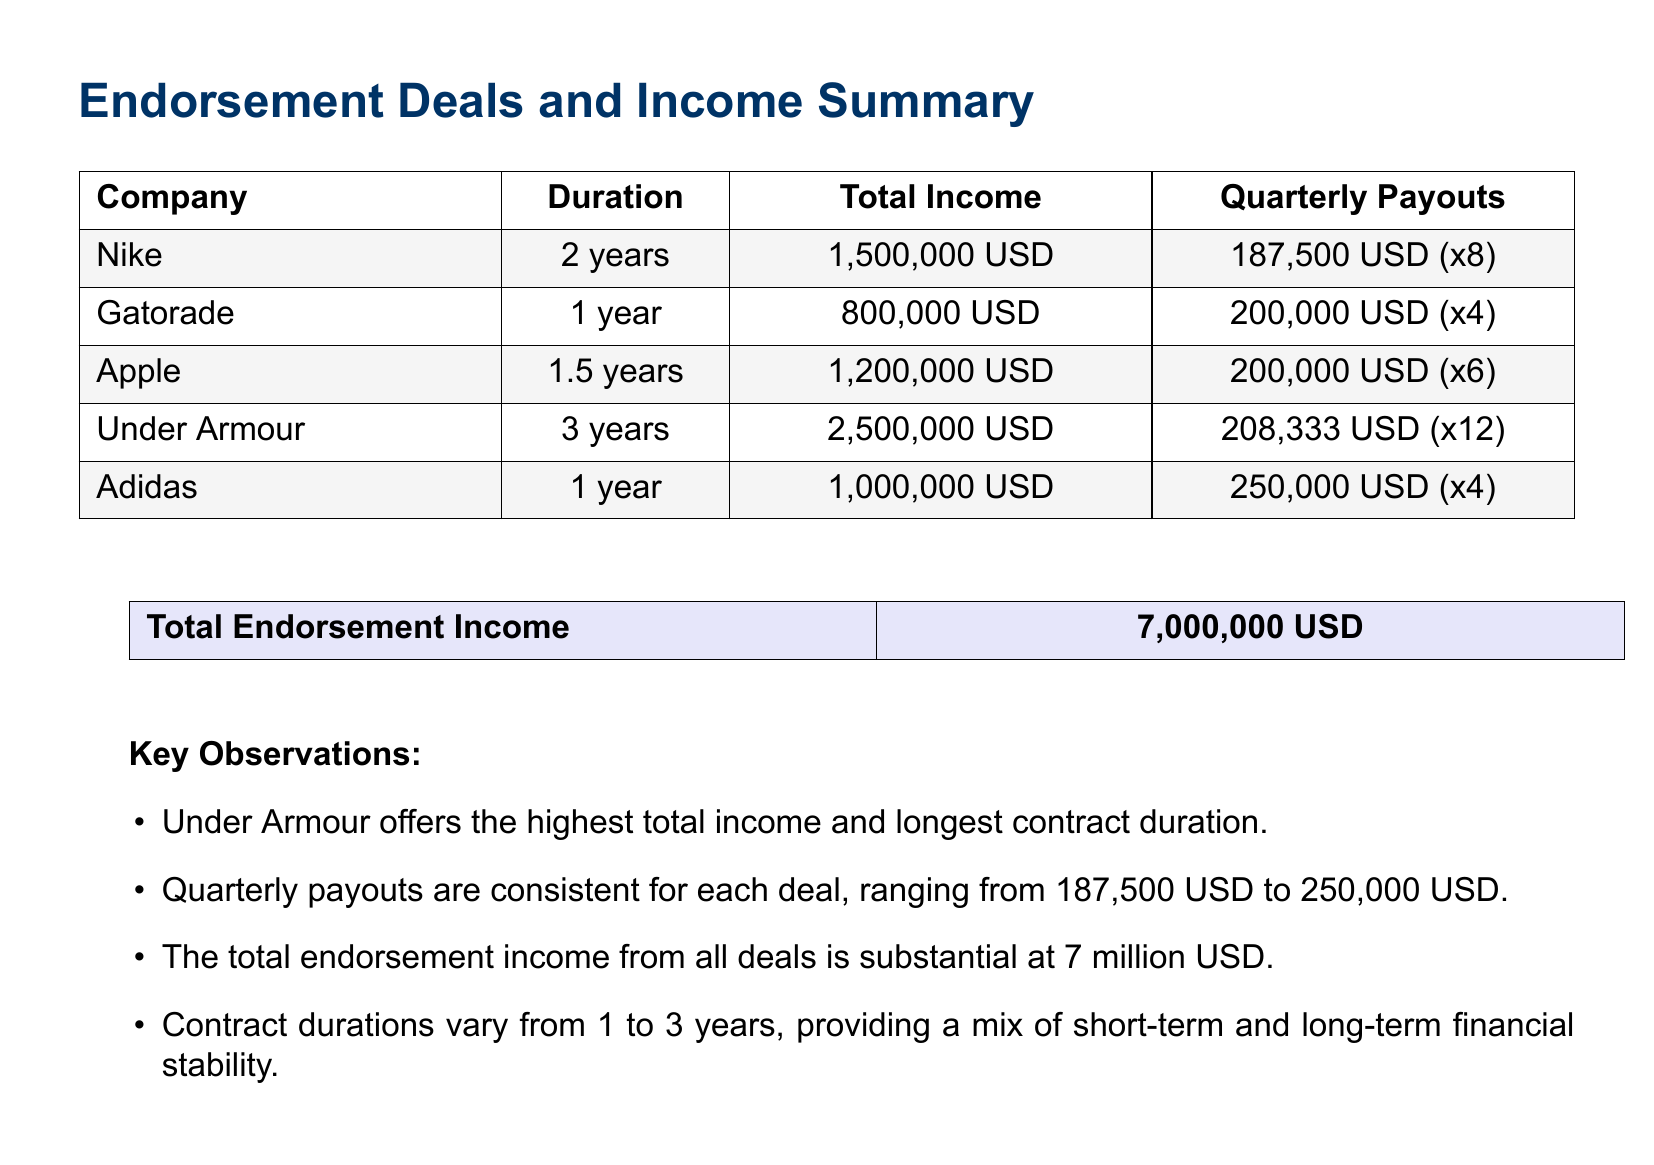What is the total endorsement income? The total endorsement income is listed at the end section of the document as the sum of all endorsement deals.
Answer: 7,000,000 USD Which company has the longest contract duration? The company with the longest contract duration is identified in the table, showing clear durations next to each company.
Answer: Under Armour How much does Nike pay quarterly? The quarterly payout for each company is listed in the respective row; for Nike, this is mentioned directly.
Answer: 187,500 USD What is the duration of the Adidas deal? The duration for Adidas is mentioned directly in the second column of the table that lists all endorsement deals.
Answer: 1 year Which company offers the highest total income? The total income figures are compared in the document, making it clear which company offers the highest amount.
Answer: Under Armour How many companies have a contract duration of 1 year? This requires counting the companies that have a duration of 1 year as listed in the document.
Answer: 2 What is the quarterly payout for Gatorade? The table indicates the quarterly payouts associated with each company; this is directly stated for Gatorade.
Answer: 200,000 USD (x4) How many endorsement deals are listed in the document? The total number of deals can be counted from the first table, providing a direct answer.
Answer: 5 What is the total income from Nike? The total income from Nike is specifically listed in the document under its corresponding row.
Answer: 1,500,000 USD 